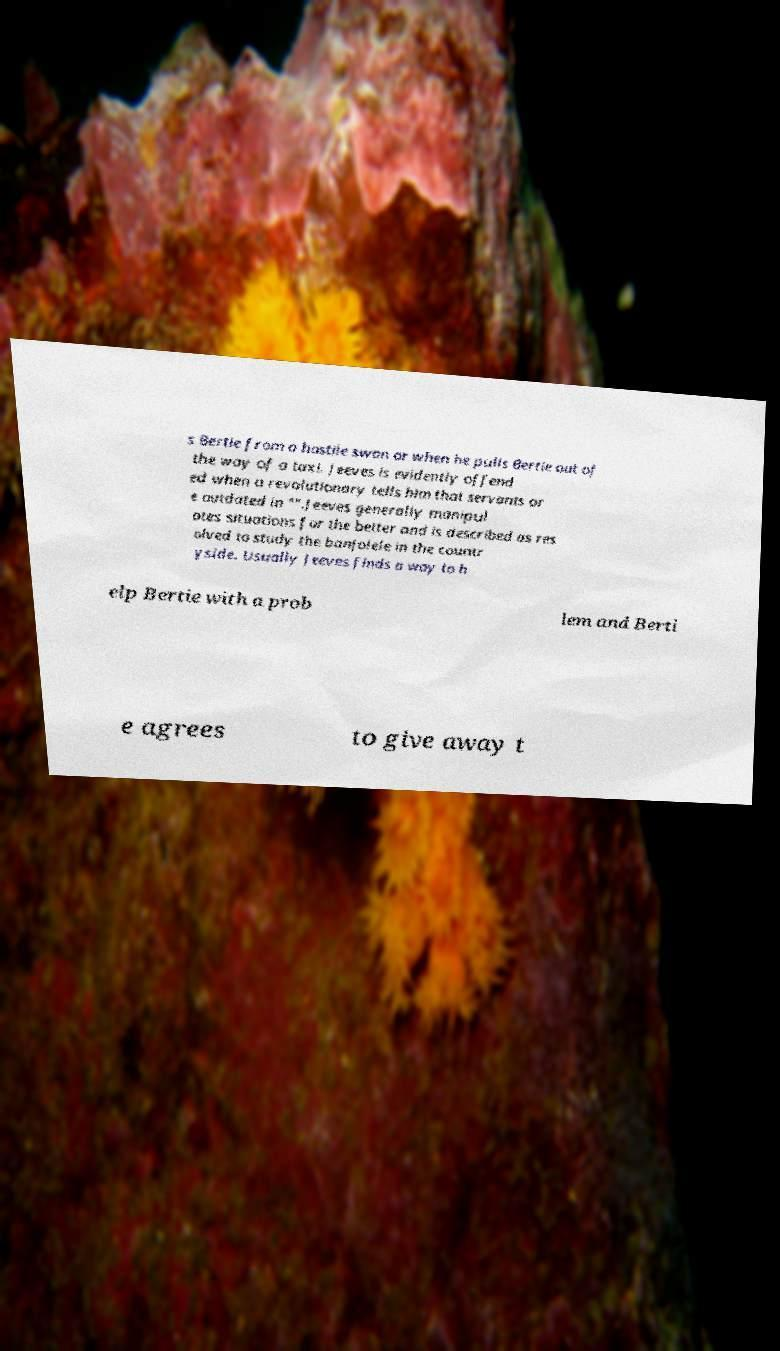For documentation purposes, I need the text within this image transcribed. Could you provide that? s Bertie from a hostile swan or when he pulls Bertie out of the way of a taxi. Jeeves is evidently offend ed when a revolutionary tells him that servants ar e outdated in "".Jeeves generally manipul ates situations for the better and is described as res olved to study the banjolele in the countr yside. Usually Jeeves finds a way to h elp Bertie with a prob lem and Berti e agrees to give away t 